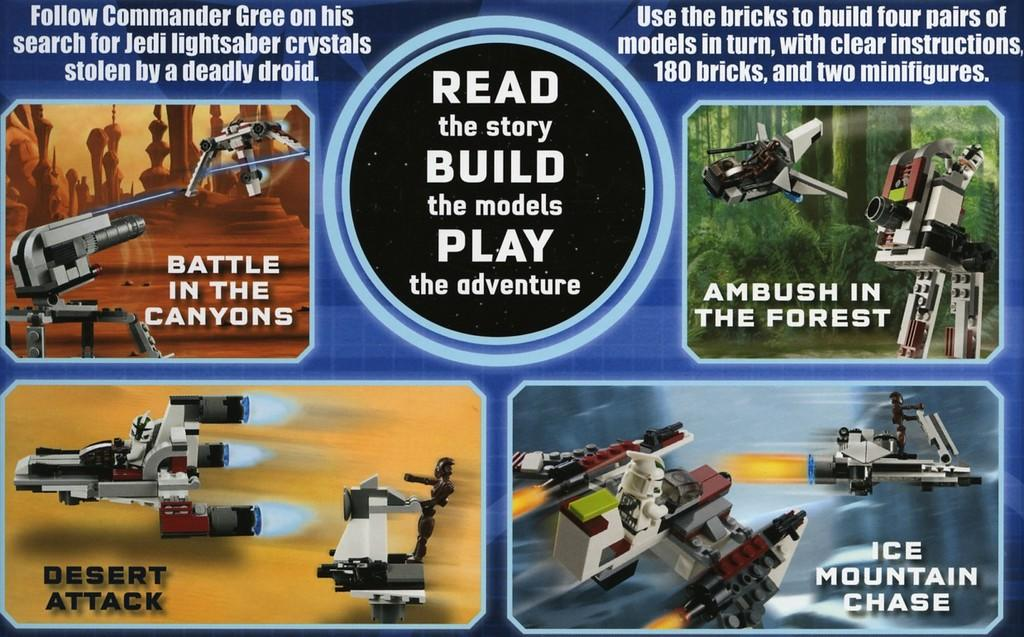<image>
Summarize the visual content of the image. An advertisement for a science fiction based brick toy set. 